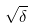Convert formula to latex. <formula><loc_0><loc_0><loc_500><loc_500>\sqrt { \delta }</formula> 